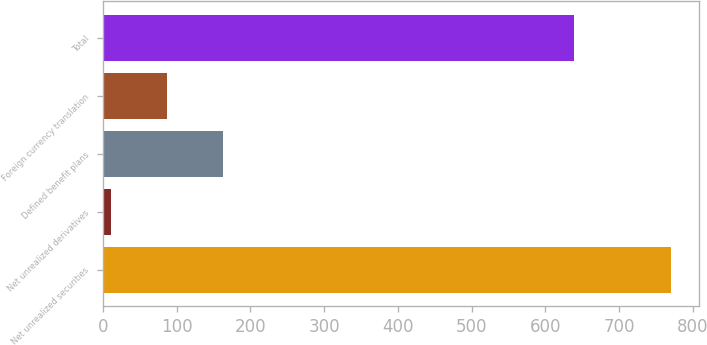Convert chart to OTSL. <chart><loc_0><loc_0><loc_500><loc_500><bar_chart><fcel>Net unrealized securities<fcel>Net unrealized derivatives<fcel>Defined benefit plans<fcel>Foreign currency translation<fcel>Total<nl><fcel>770<fcel>11<fcel>162.8<fcel>86.9<fcel>638<nl></chart> 